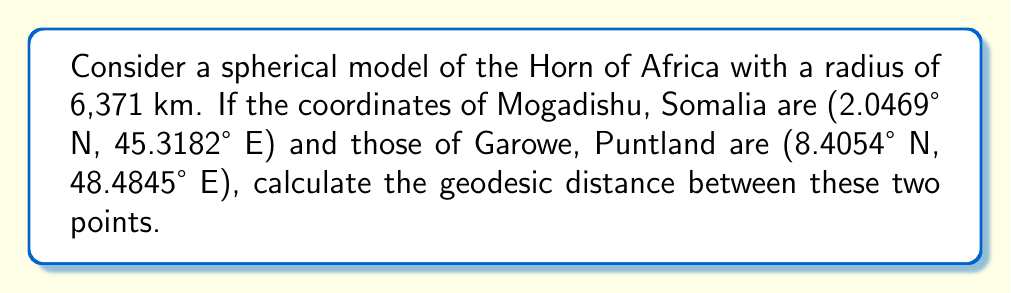Can you answer this question? To solve this problem, we'll use the Haversine formula, which determines the great-circle distance between two points on a sphere given their longitudes and latitudes. Let's proceed step-by-step:

1) Convert the coordinates to radians:
   Mogadishu: $\phi_1 = 2.0469° \times \frac{\pi}{180} = 0.0357$ rad, $\lambda_1 = 45.3182° \times \frac{\pi}{180} = 0.7909$ rad
   Garowe: $\phi_2 = 8.4054° \times \frac{\pi}{180} = 0.1467$ rad, $\lambda_2 = 48.4845° \times \frac{\pi}{180} = 0.8462$ rad

2) Calculate the difference in longitude: $\Delta \lambda = \lambda_2 - \lambda_1 = 0.8462 - 0.7909 = 0.0553$ rad

3) Apply the Haversine formula:
   $$a = \sin^2\left(\frac{\Delta\phi}{2}\right) + \cos(\phi_1) \cos(\phi_2) \sin^2\left(\frac{\Delta\lambda}{2}\right)$$
   
   $$a = \sin^2\left(\frac{0.1467 - 0.0357}{2}\right) + \cos(0.0357) \cos(0.1467) \sin^2\left(\frac{0.0553}{2}\right) = 0.0030$$

4) Calculate the central angle:
   $$c = 2 \times \arctan2(\sqrt{a}, \sqrt{1-a}) = 2 \times \arctan2(\sqrt{0.0030}, \sqrt{1-0.0030}) = 0.1095$$ rad

5) Determine the geodesic distance:
   $$d = R \times c = 6371 \times 0.1095 = 697.6$$ km

This distance represents the shortest path between Mogadishu and Garowe on the surface of our spherical model of the Horn of Africa.
Answer: 697.6 km 